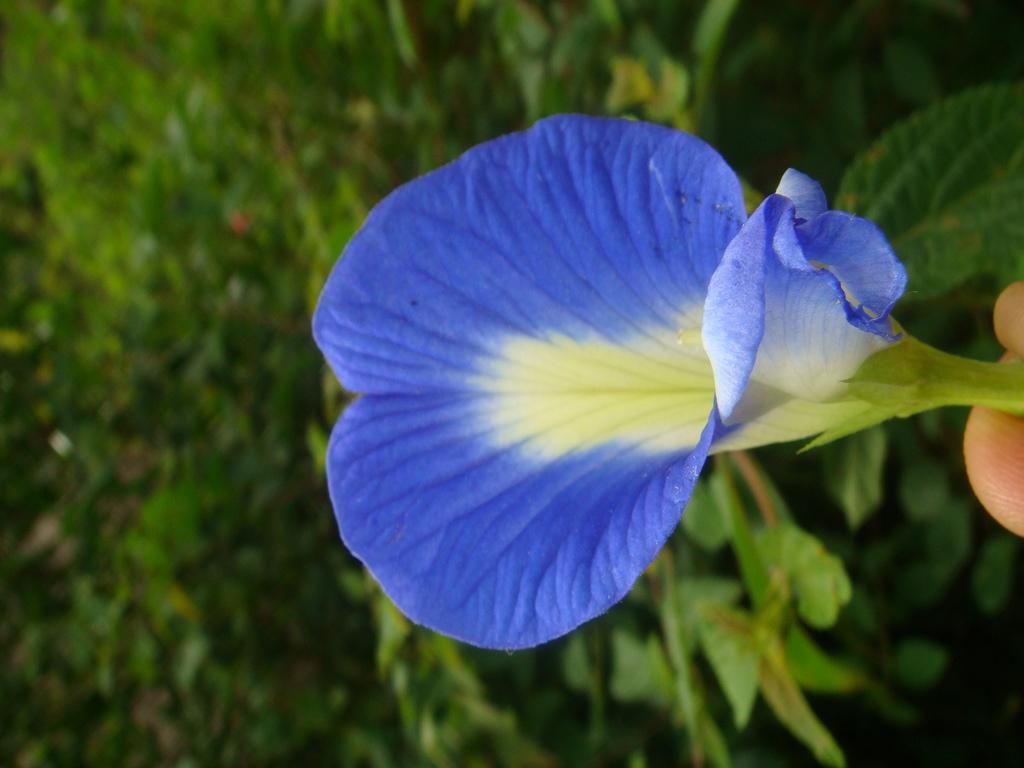In one or two sentences, can you explain what this image depicts? In this picture we can see a blue flower and behind the flower there are plants. 